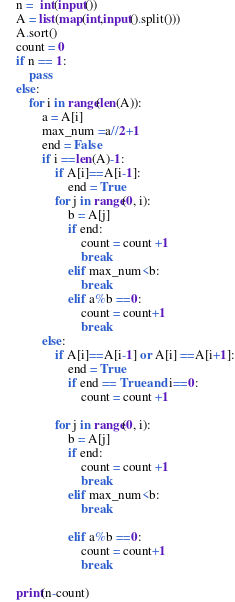Convert code to text. <code><loc_0><loc_0><loc_500><loc_500><_Python_>n =  int(input())
A = list(map(int,input().split()))
A.sort()
count = 0
if n == 1:
    pass
else:
    for i in range(len(A)):
        a = A[i]
        max_num =a//2+1
        end = False
        if i ==len(A)-1:
            if A[i]==A[i-1]:
                end = True
            for j in range(0, i):
                b = A[j]
                if end:
                    count = count +1
                    break
                elif max_num<b:
                    break
                elif a%b ==0:
                    count = count+1
                    break
        else:
            if A[i]==A[i-1] or A[i] ==A[i+1]:
                end = True
                if end == True and i==0:
                    count = count +1

            for j in range(0, i):
                b = A[j]
                if end:
                    count = count +1
                    break
                elif max_num<b:
                    break
                    
                elif a%b ==0:
                    count = count+1
                    break

print(n-count)</code> 